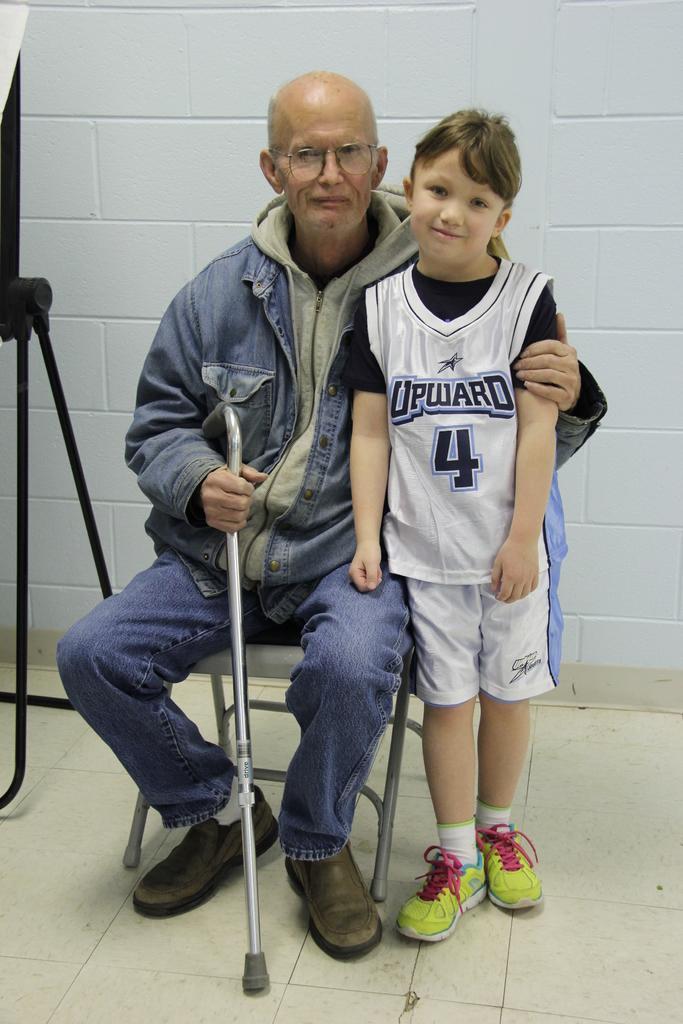Can you describe this image briefly? In this image I can see a man and a boy. I can also see he is sitting on a chair and holding a stick. 